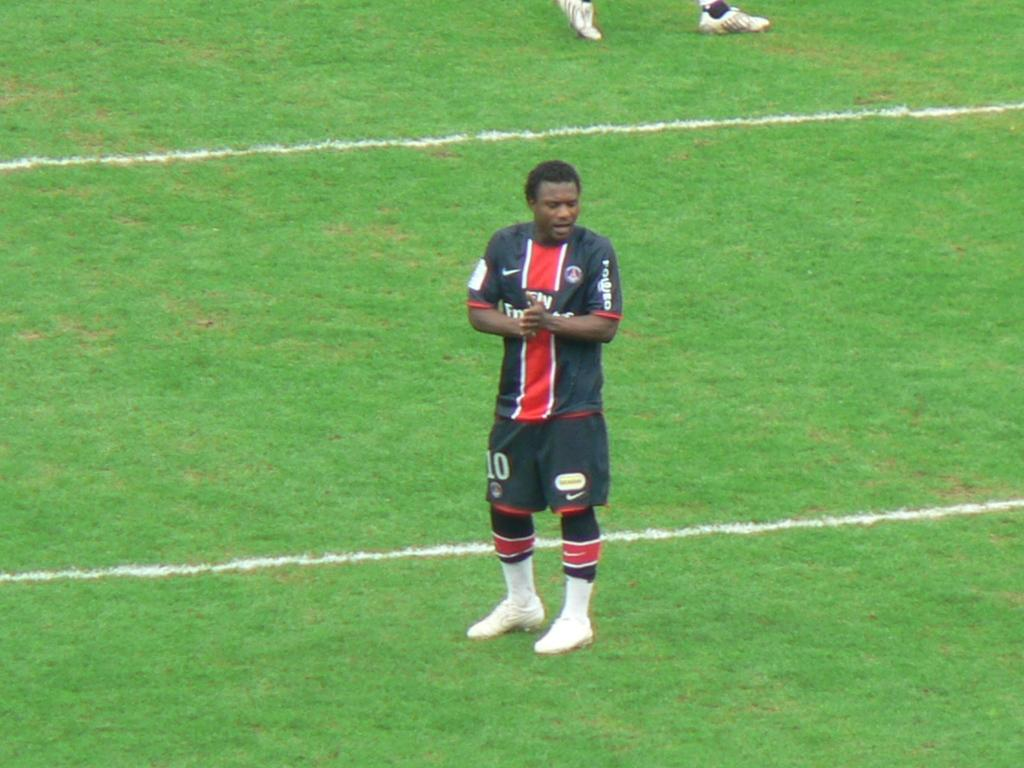<image>
Offer a succinct explanation of the picture presented. A man standing in a green field wearing a uniform with the shorts having the number 10 